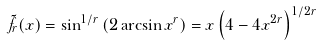<formula> <loc_0><loc_0><loc_500><loc_500>\tilde { f } _ { r } ( x ) = \sin ^ { 1 / r } \left ( 2 \arcsin x ^ { r } \right ) = x \left ( 4 - 4 x ^ { 2 r } \right ) ^ { 1 / 2 r }</formula> 